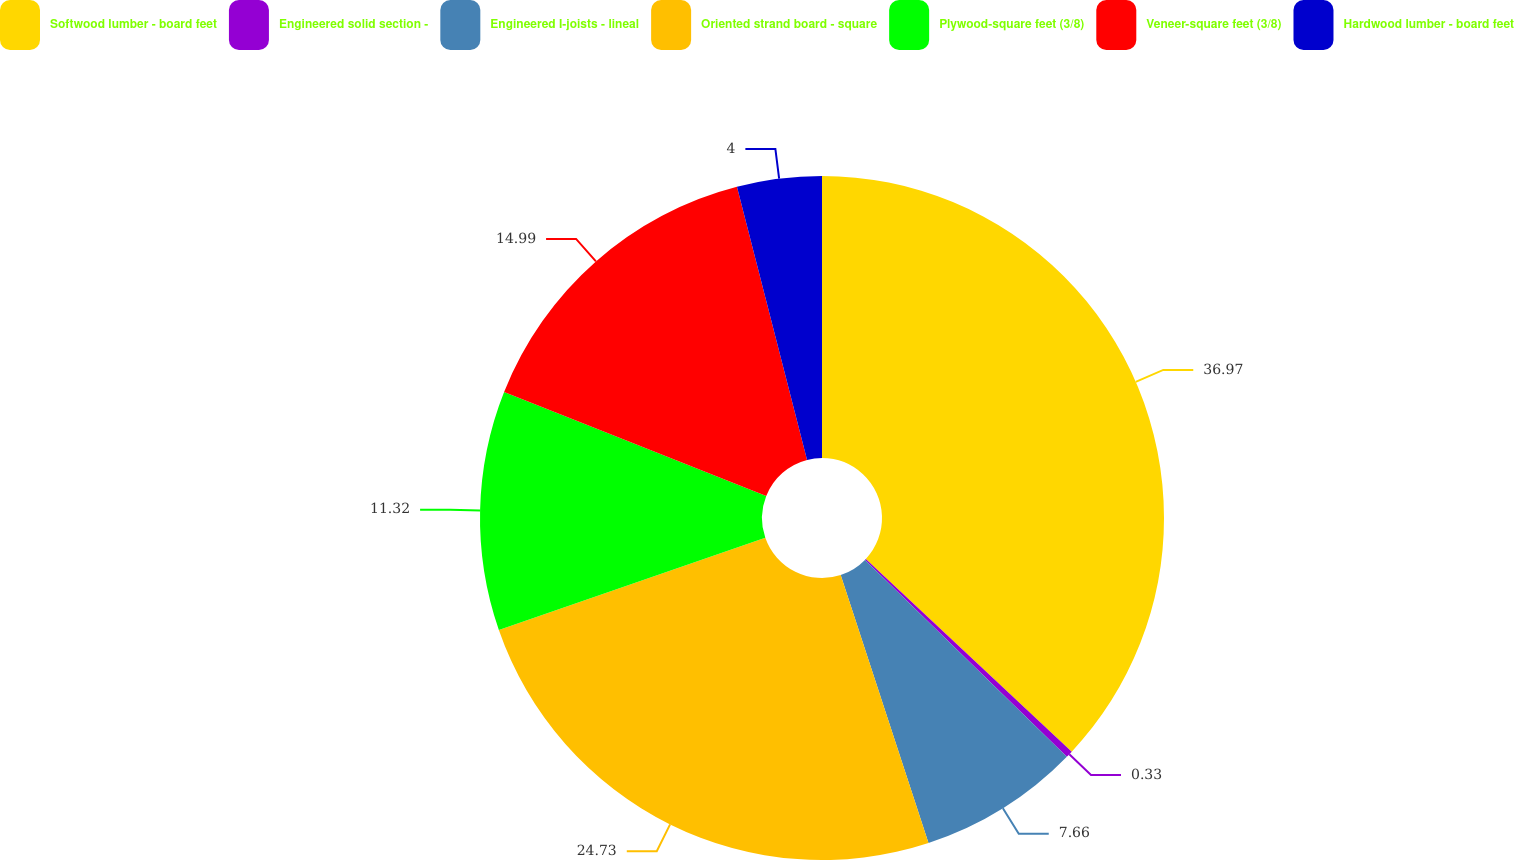<chart> <loc_0><loc_0><loc_500><loc_500><pie_chart><fcel>Softwood lumber - board feet<fcel>Engineered solid section -<fcel>Engineered I-joists - lineal<fcel>Oriented strand board - square<fcel>Plywood-square feet (3/8)<fcel>Veneer-square feet (3/8)<fcel>Hardwood lumber - board feet<nl><fcel>36.97%<fcel>0.33%<fcel>7.66%<fcel>24.73%<fcel>11.32%<fcel>14.99%<fcel>4.0%<nl></chart> 